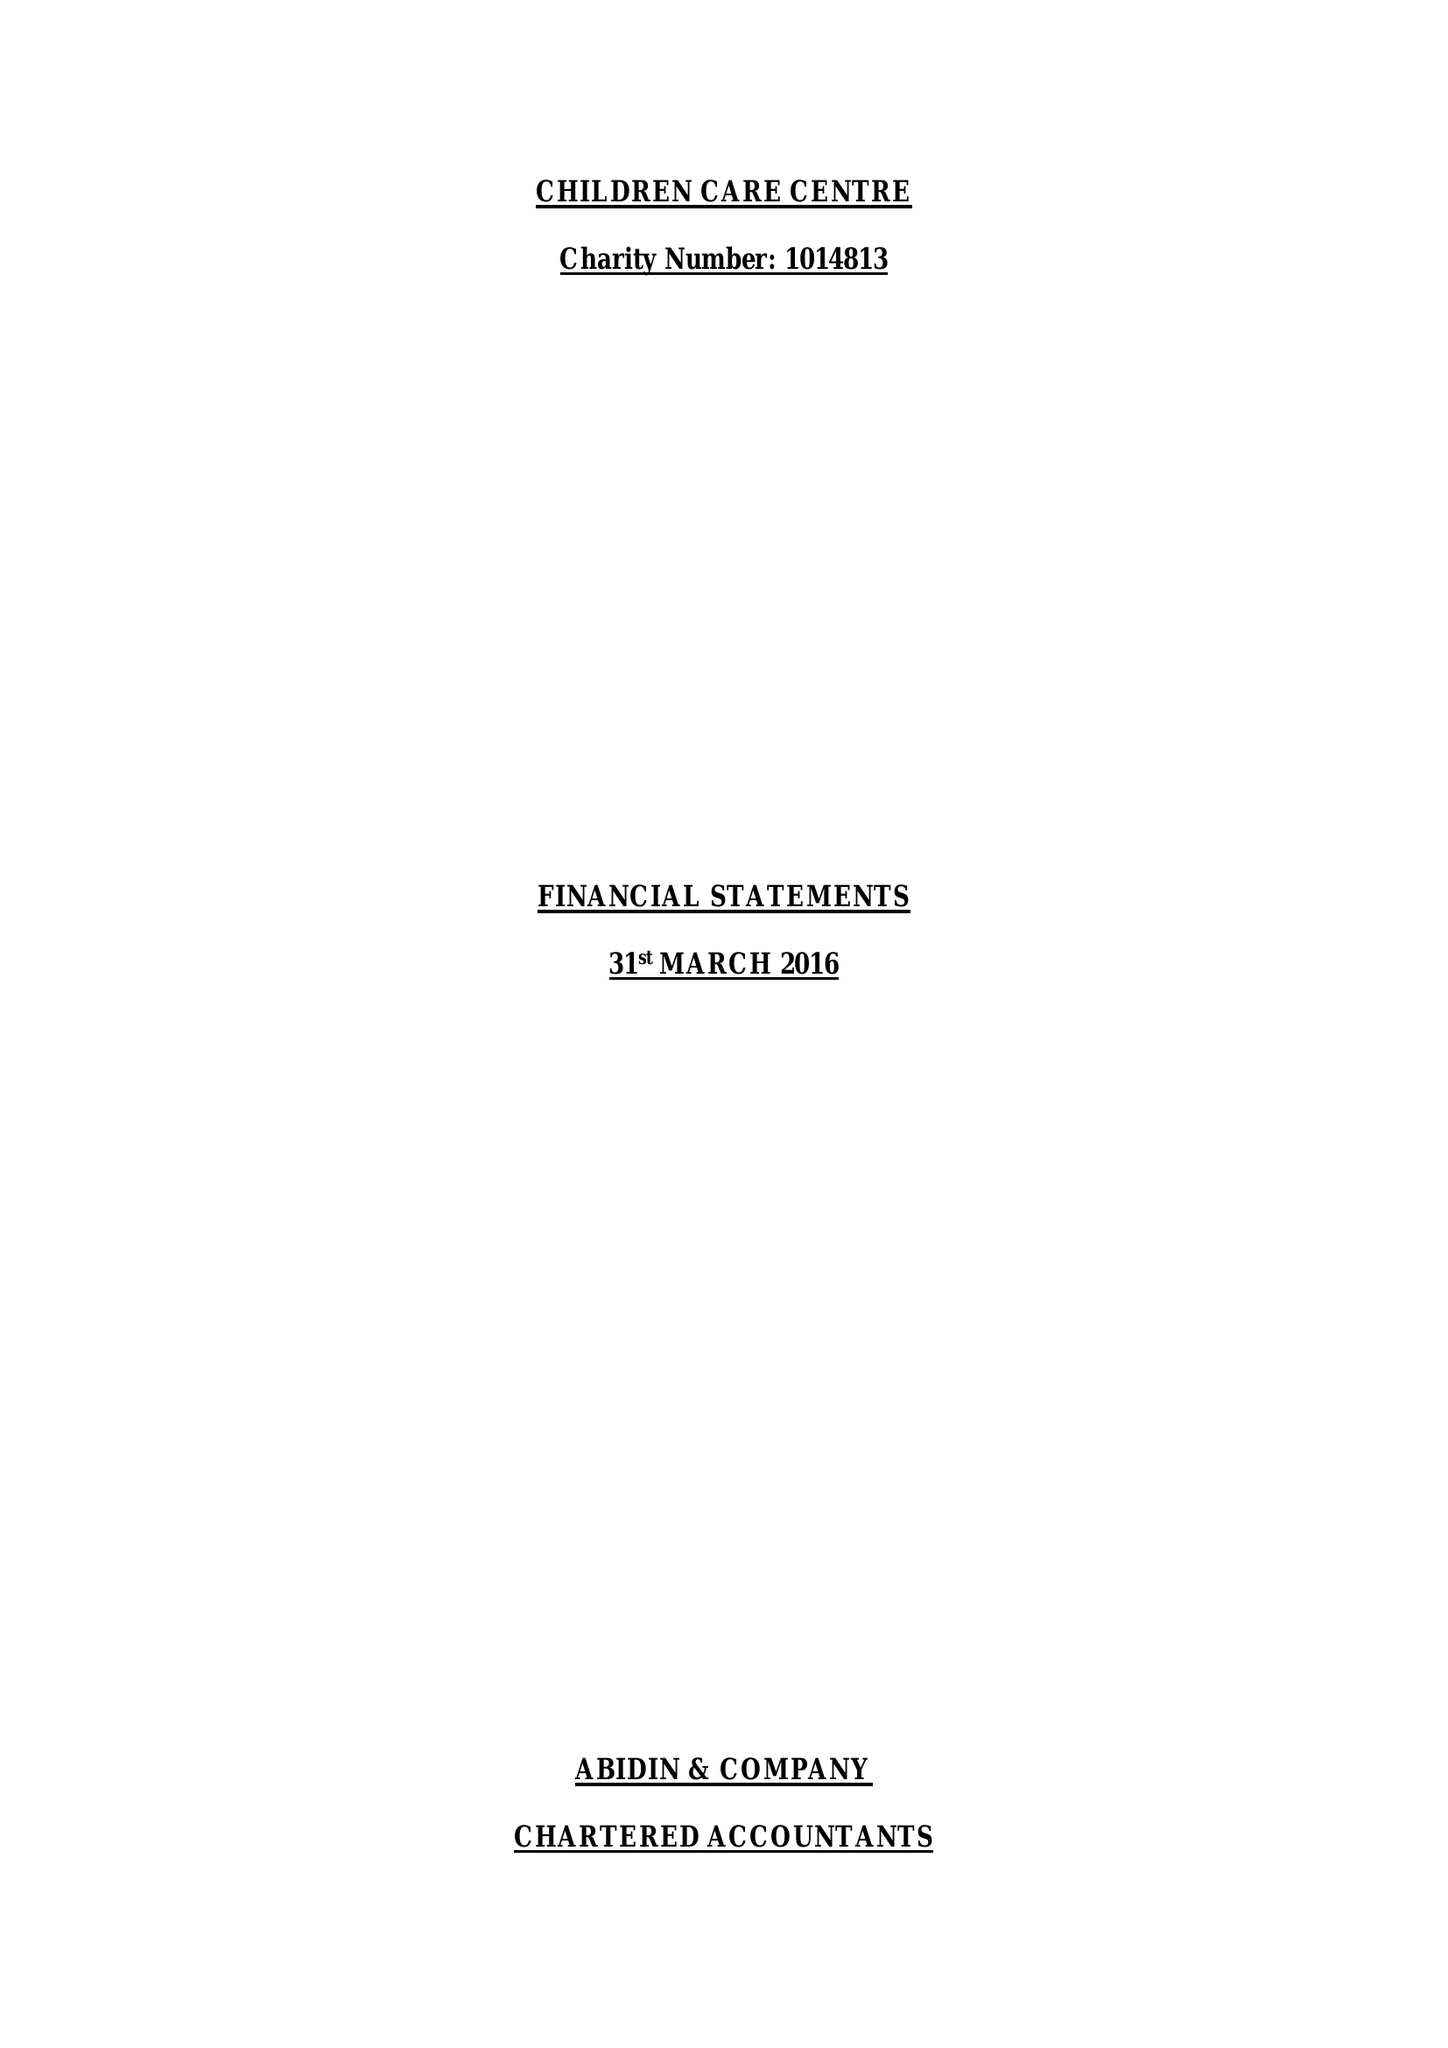What is the value for the address__postcode?
Answer the question using a single word or phrase. E7 0NU 